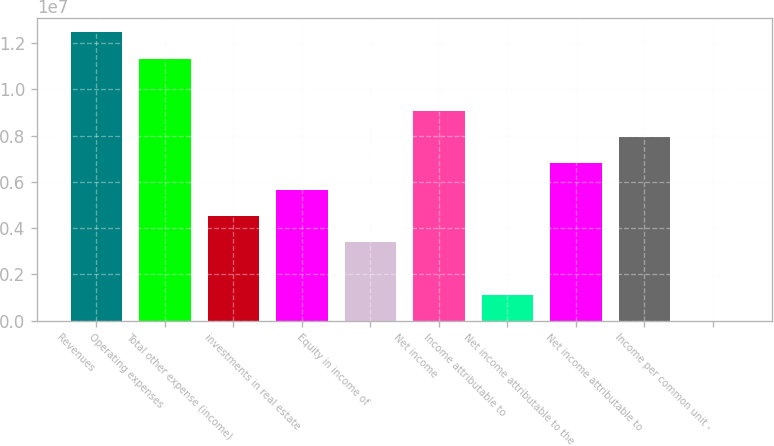<chart> <loc_0><loc_0><loc_500><loc_500><bar_chart><fcel>Revenues<fcel>Operating expenses<fcel>Total other expense (income)<fcel>investments in real estate<fcel>Equity in income of<fcel>Net income<fcel>Income attributable to<fcel>Net income attributable to the<fcel>Net income attributable to<fcel>Income per common unit -<nl><fcel>1.24588e+07<fcel>1.13262e+07<fcel>4.53047e+06<fcel>5.66308e+06<fcel>3.39785e+06<fcel>9.06093e+06<fcel>1.13262e+06<fcel>6.7957e+06<fcel>7.92831e+06<fcel>1.46<nl></chart> 